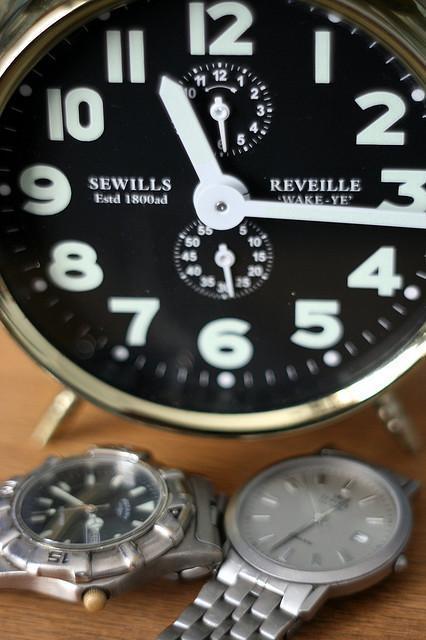How many clocks are in the picture?
Give a very brief answer. 3. 